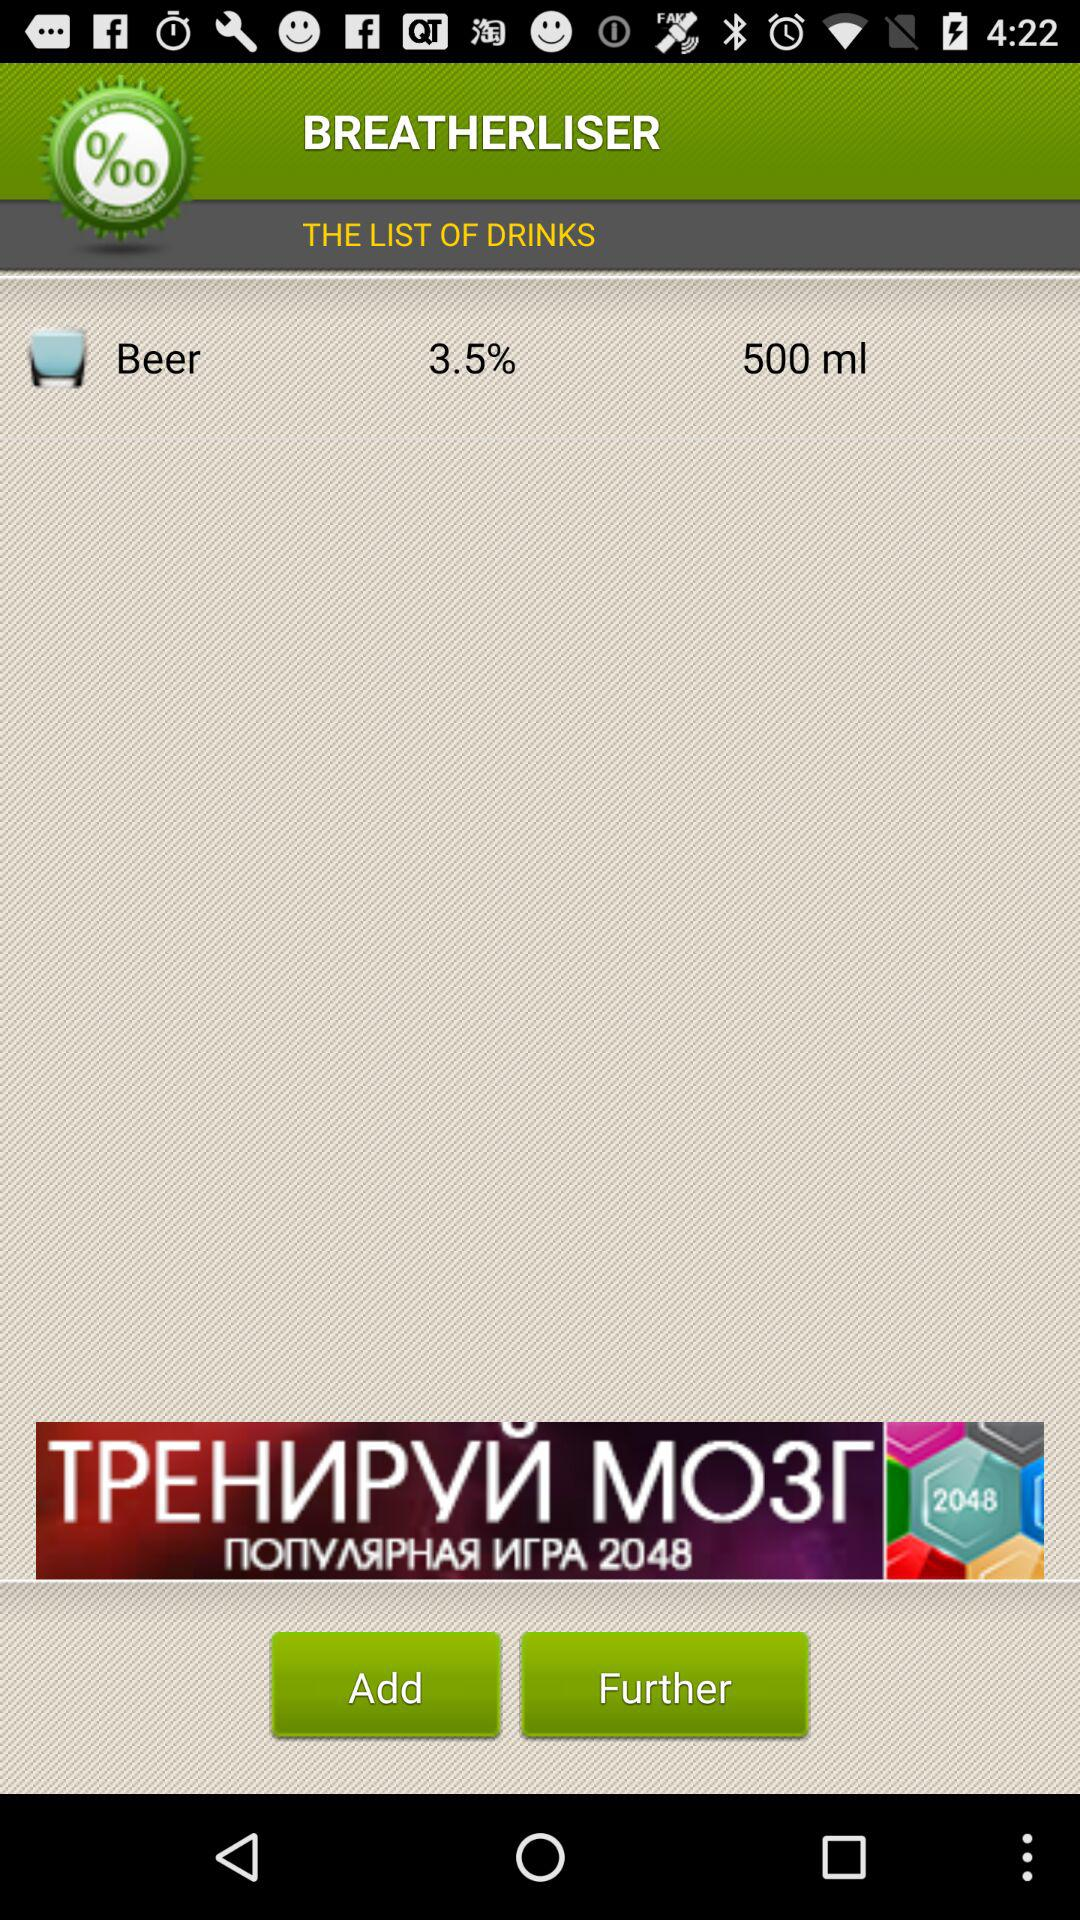What is the alcohol content of the beer?
Answer the question using a single word or phrase. 3.5% 